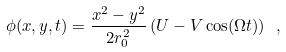Convert formula to latex. <formula><loc_0><loc_0><loc_500><loc_500>\phi ( x , y , t ) = \frac { x ^ { 2 } - y ^ { 2 } } { 2 r _ { 0 } ^ { 2 } } \left ( U - V \cos ( \Omega t ) \right ) \ ,</formula> 